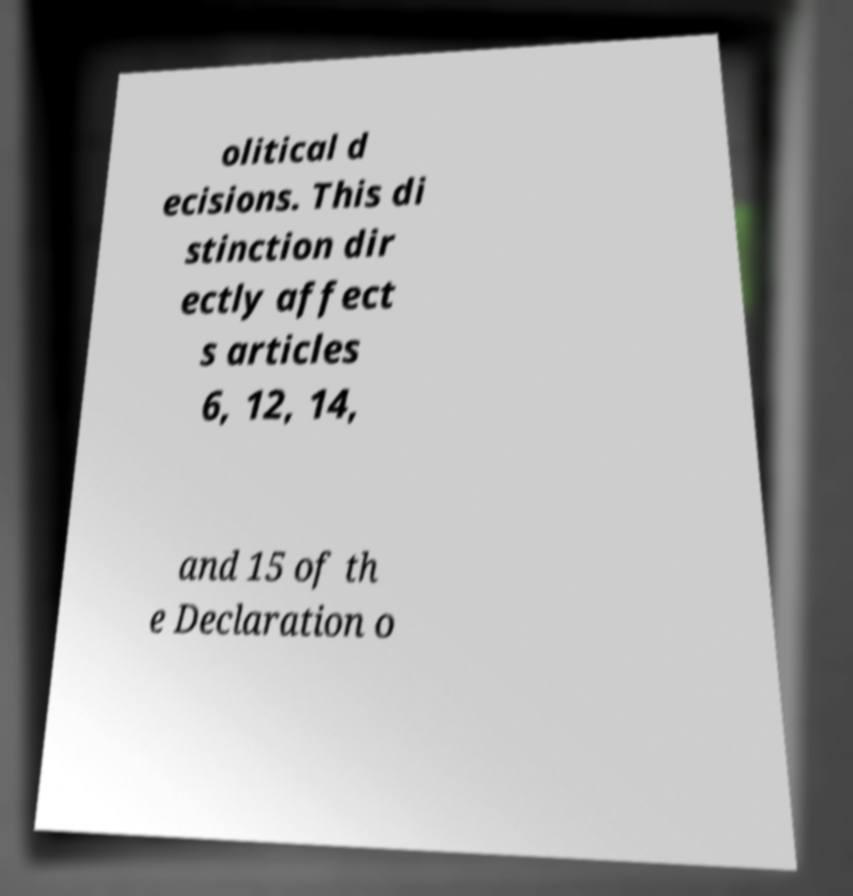For documentation purposes, I need the text within this image transcribed. Could you provide that? olitical d ecisions. This di stinction dir ectly affect s articles 6, 12, 14, and 15 of th e Declaration o 